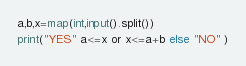<code> <loc_0><loc_0><loc_500><loc_500><_Python_>a,b,x=map(int,input().split())
print("YES" a<=x or x<=a+b else "NO" )</code> 